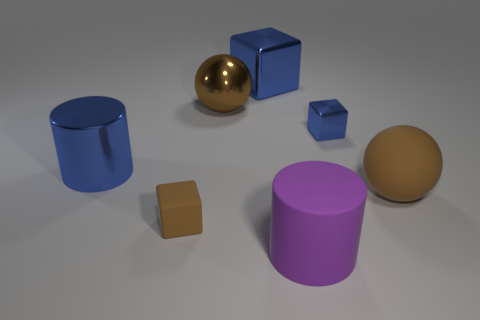The purple cylinder that is the same material as the small brown object is what size?
Offer a terse response. Large. There is a thing that is in front of the blue cylinder and behind the brown matte block; what color is it?
Provide a succinct answer. Brown. How many brown rubber cubes are the same size as the brown rubber sphere?
Offer a very short reply. 0. What size is the other rubber object that is the same color as the small matte thing?
Your answer should be compact. Large. There is a brown thing that is right of the brown block and left of the purple rubber cylinder; what size is it?
Your answer should be very brief. Large. There is a large blue metal object on the left side of the brown metallic thing behind the brown cube; what number of tiny matte objects are behind it?
Your answer should be very brief. 0. Are there any big metal things of the same color as the rubber cylinder?
Your response must be concise. No. What is the color of the block that is the same size as the shiny sphere?
Your response must be concise. Blue. The large blue thing that is behind the big ball behind the metal thing in front of the tiny blue thing is what shape?
Your response must be concise. Cube. What number of matte objects are behind the blue shiny thing to the right of the purple object?
Give a very brief answer. 0. 